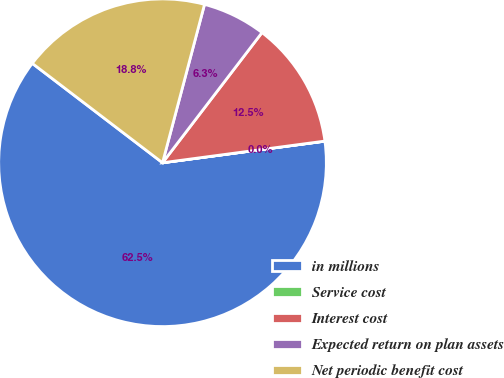<chart> <loc_0><loc_0><loc_500><loc_500><pie_chart><fcel>in millions<fcel>Service cost<fcel>Interest cost<fcel>Expected return on plan assets<fcel>Net periodic benefit cost<nl><fcel>62.47%<fcel>0.01%<fcel>12.5%<fcel>6.26%<fcel>18.75%<nl></chart> 